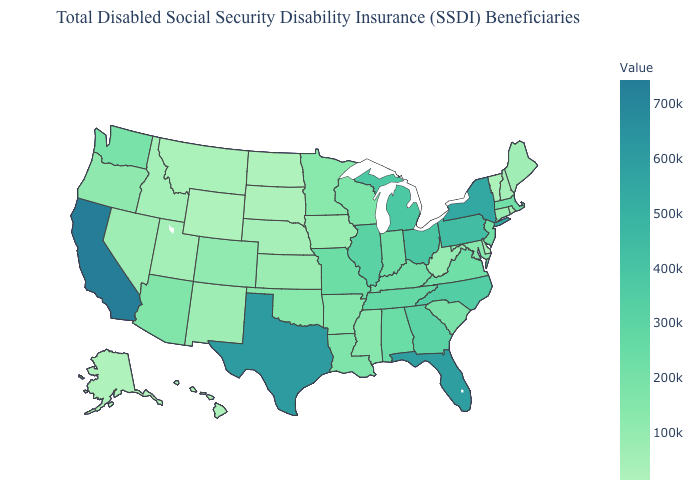Does Washington have a higher value than Tennessee?
Concise answer only. No. Is the legend a continuous bar?
Quick response, please. Yes. Does Connecticut have a higher value than Kentucky?
Short answer required. No. Is the legend a continuous bar?
Write a very short answer. Yes. Does Colorado have the lowest value in the West?
Answer briefly. No. 